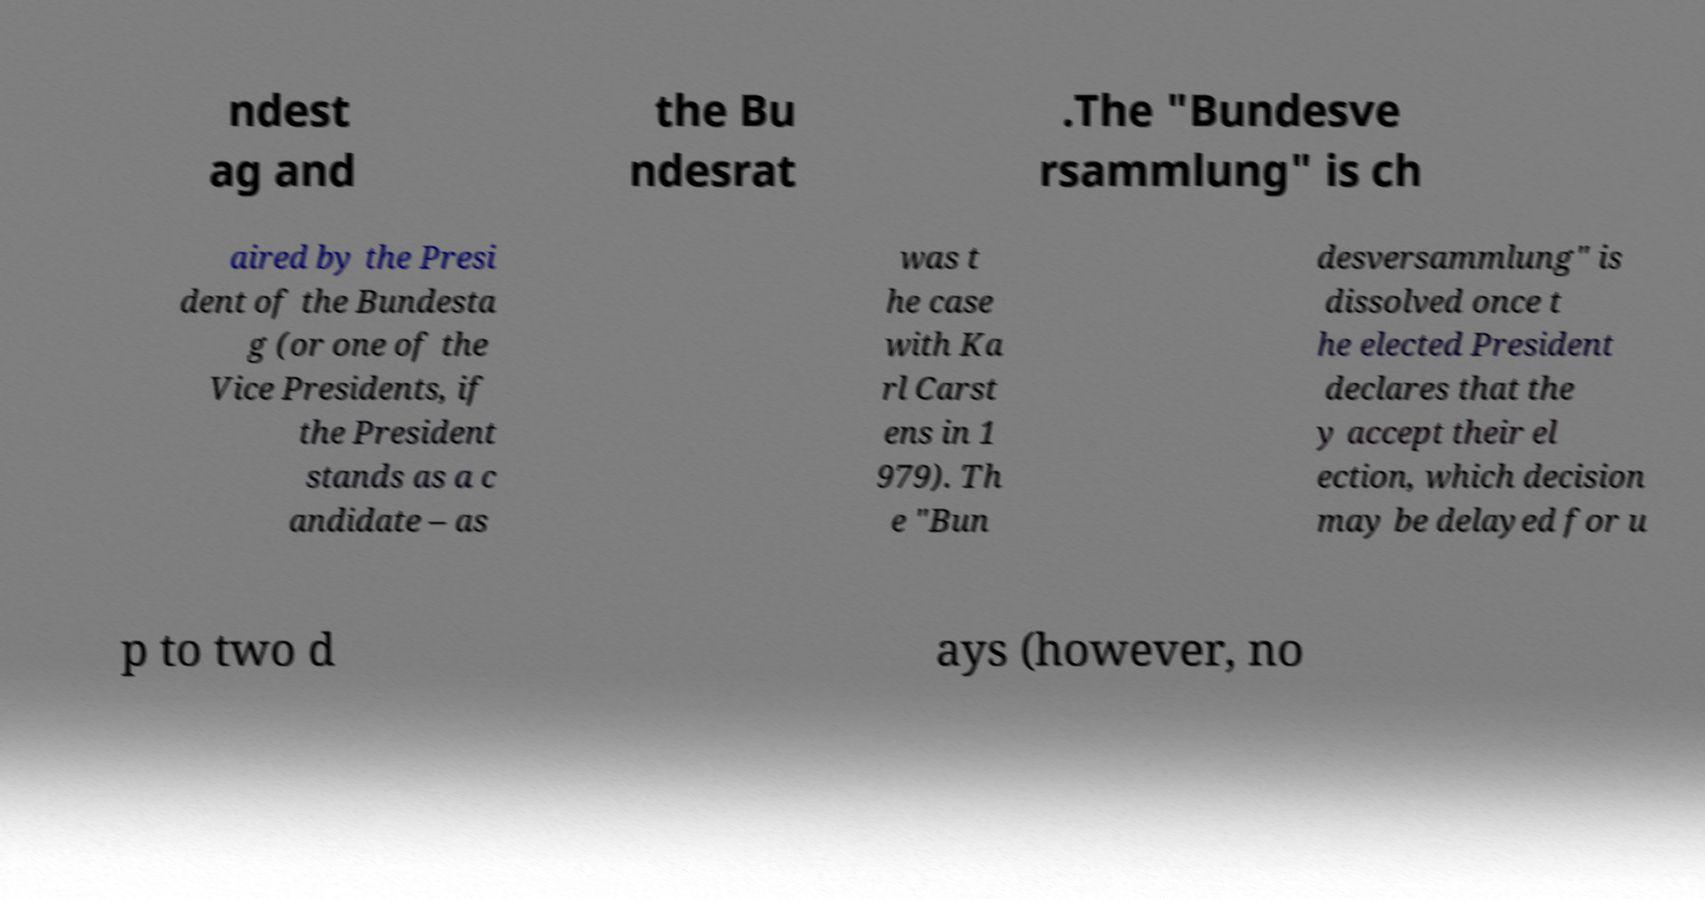Could you assist in decoding the text presented in this image and type it out clearly? ndest ag and the Bu ndesrat .The "Bundesve rsammlung" is ch aired by the Presi dent of the Bundesta g (or one of the Vice Presidents, if the President stands as a c andidate – as was t he case with Ka rl Carst ens in 1 979). Th e "Bun desversammlung" is dissolved once t he elected President declares that the y accept their el ection, which decision may be delayed for u p to two d ays (however, no 